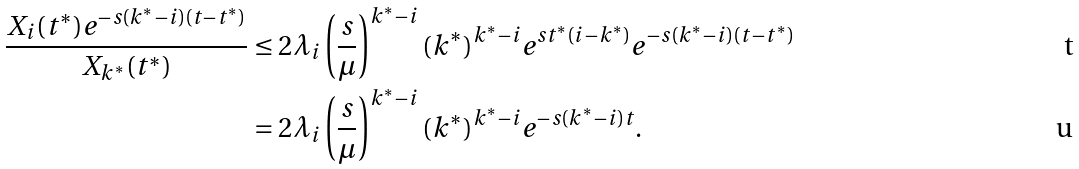Convert formula to latex. <formula><loc_0><loc_0><loc_500><loc_500>\frac { X _ { i } ( t ^ { * } ) e ^ { - s ( k ^ { * } - i ) ( t - t ^ { * } ) } } { X _ { k ^ { * } } ( t ^ { * } ) } & \leq 2 \lambda _ { i } \left ( \frac { s } { \mu } \right ) ^ { k ^ { * } - i } ( k ^ { * } ) ^ { k ^ { * } - i } e ^ { s t ^ { * } ( i - k ^ { * } ) } e ^ { - s ( k ^ { * } - i ) ( t - t ^ { * } ) } \\ & = 2 \lambda _ { i } \left ( \frac { s } { \mu } \right ) ^ { k ^ { * } - i } ( k ^ { * } ) ^ { k ^ { * } - i } e ^ { - s ( k ^ { * } - i ) t } .</formula> 